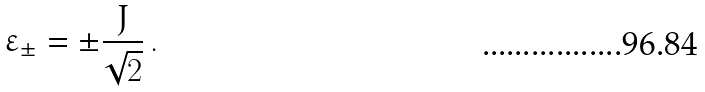<formula> <loc_0><loc_0><loc_500><loc_500>\varepsilon _ { \pm } = \pm \frac { J } { \sqrt { 2 } } \, .</formula> 